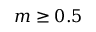Convert formula to latex. <formula><loc_0><loc_0><loc_500><loc_500>m \geq 0 . 5</formula> 